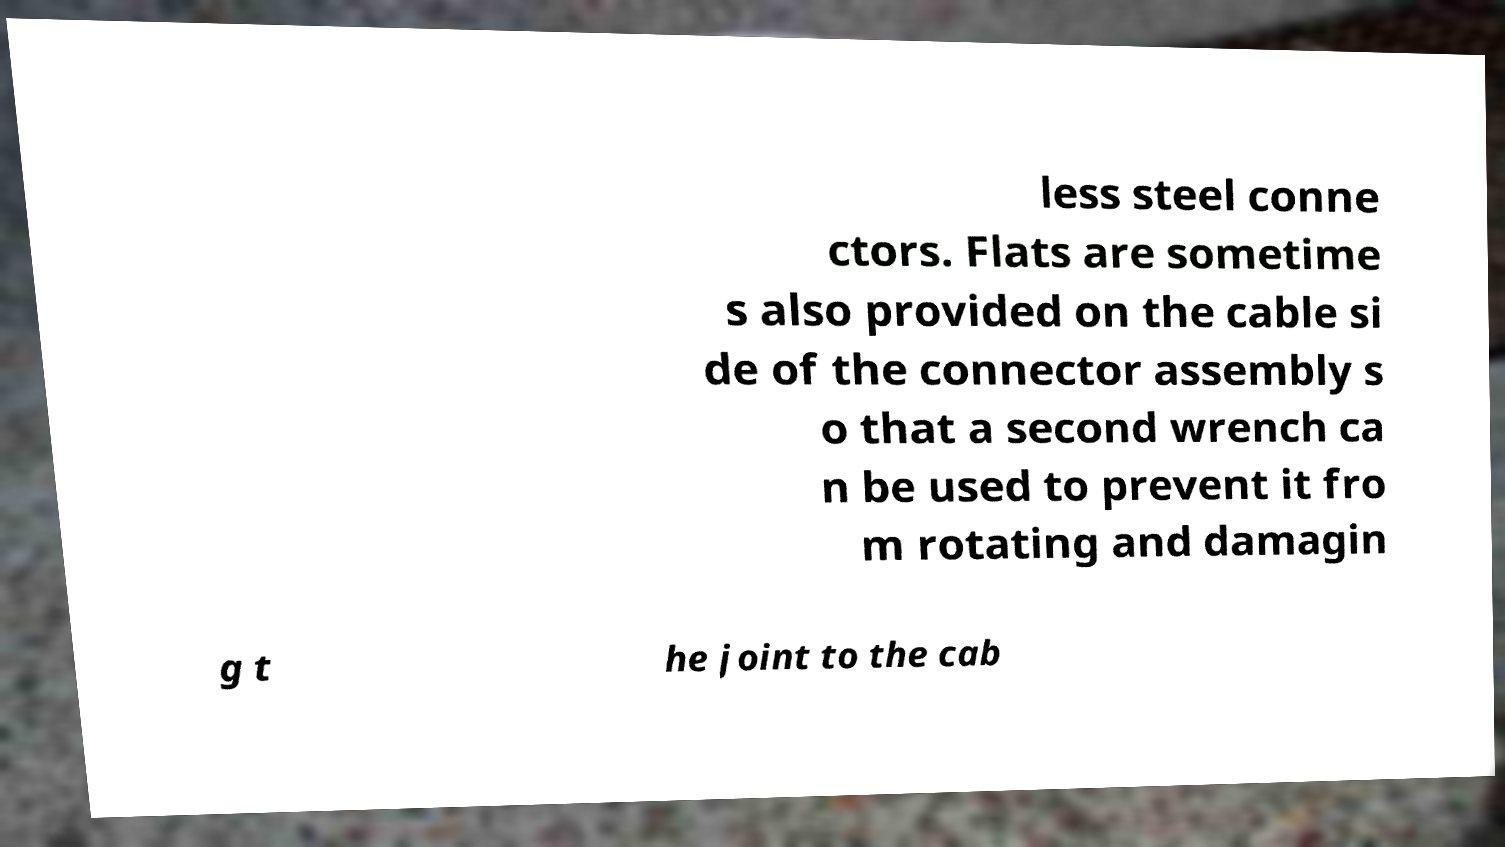Could you extract and type out the text from this image? less steel conne ctors. Flats are sometime s also provided on the cable si de of the connector assembly s o that a second wrench ca n be used to prevent it fro m rotating and damagin g t he joint to the cab 